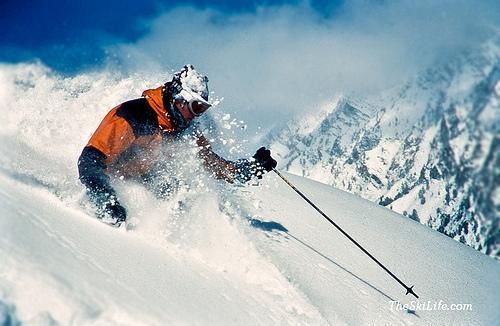How many skiers are there?
Give a very brief answer. 1. 